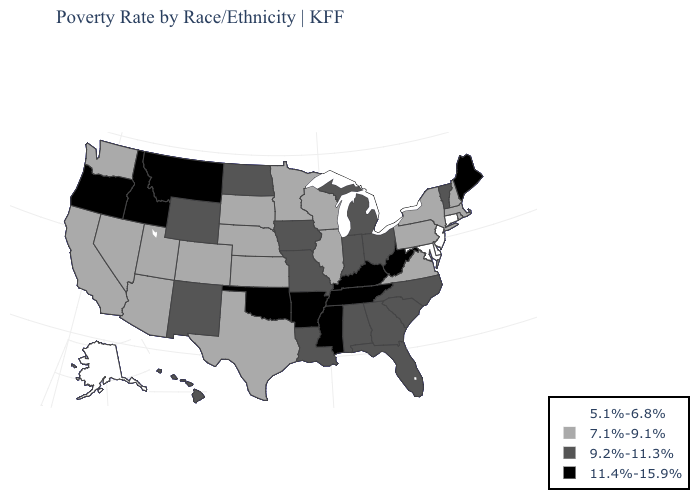What is the value of Connecticut?
Short answer required. 5.1%-6.8%. Name the states that have a value in the range 11.4%-15.9%?
Short answer required. Arkansas, Idaho, Kentucky, Maine, Mississippi, Montana, Oklahoma, Oregon, Tennessee, West Virginia. Name the states that have a value in the range 9.2%-11.3%?
Keep it brief. Alabama, Florida, Georgia, Hawaii, Indiana, Iowa, Louisiana, Michigan, Missouri, New Mexico, North Carolina, North Dakota, Ohio, South Carolina, Vermont, Wyoming. Does Connecticut have the highest value in the Northeast?
Write a very short answer. No. Is the legend a continuous bar?
Keep it brief. No. How many symbols are there in the legend?
Keep it brief. 4. What is the lowest value in the USA?
Keep it brief. 5.1%-6.8%. What is the lowest value in the USA?
Quick response, please. 5.1%-6.8%. What is the value of Iowa?
Short answer required. 9.2%-11.3%. What is the value of Maine?
Quick response, please. 11.4%-15.9%. Name the states that have a value in the range 11.4%-15.9%?
Write a very short answer. Arkansas, Idaho, Kentucky, Maine, Mississippi, Montana, Oklahoma, Oregon, Tennessee, West Virginia. What is the value of North Carolina?
Quick response, please. 9.2%-11.3%. Which states have the lowest value in the USA?
Short answer required. Alaska, Connecticut, Delaware, Maryland, New Jersey. What is the value of North Dakota?
Be succinct. 9.2%-11.3%. 